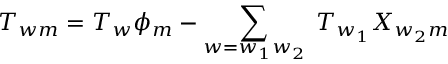Convert formula to latex. <formula><loc_0><loc_0><loc_500><loc_500>T _ { w m } = T _ { w } \phi _ { m } - \sum _ { w = w _ { 1 } w _ { 2 } } \, T _ { w _ { 1 } } X _ { w _ { 2 } m }</formula> 